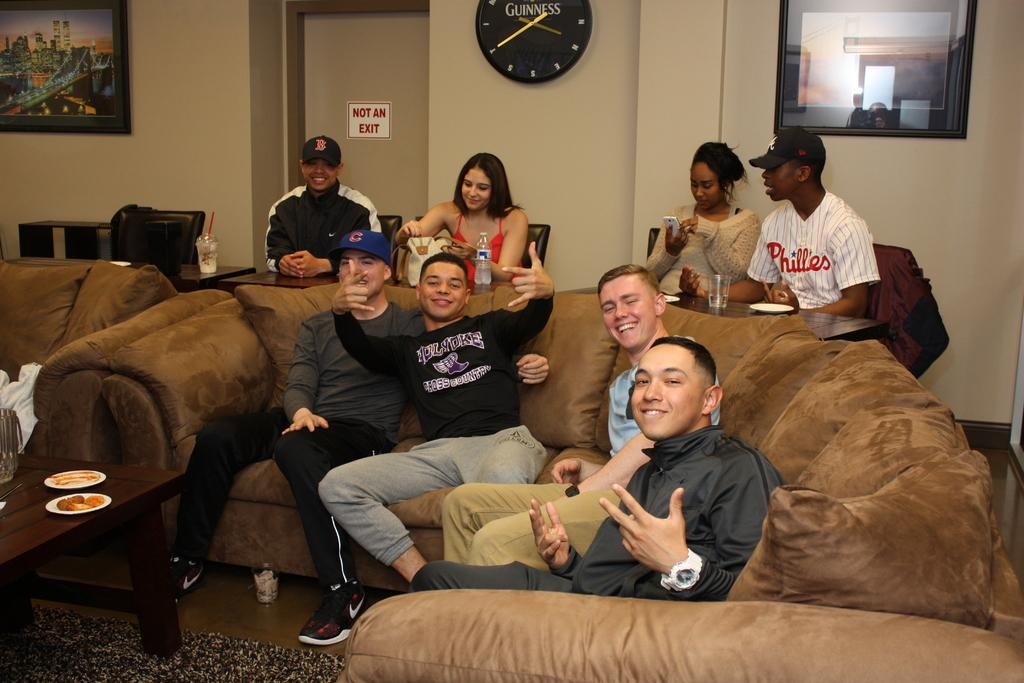<image>
Summarize the visual content of the image. A man in a shirt that says Phillies on the front sits behind a couch. 